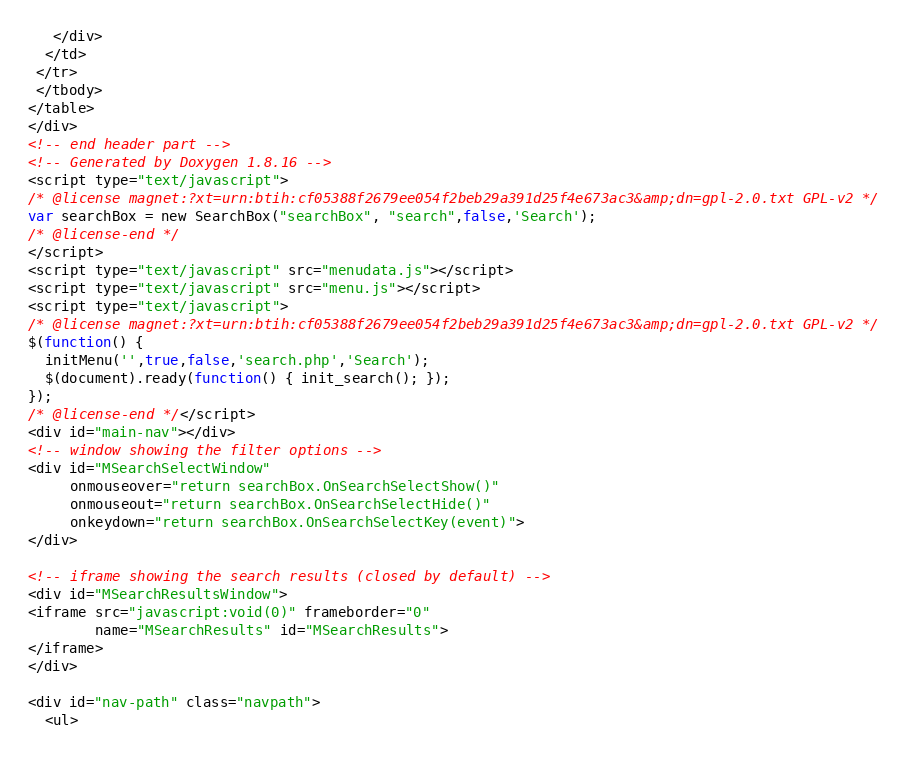Convert code to text. <code><loc_0><loc_0><loc_500><loc_500><_HTML_>   </div>
  </td>
 </tr>
 </tbody>
</table>
</div>
<!-- end header part -->
<!-- Generated by Doxygen 1.8.16 -->
<script type="text/javascript">
/* @license magnet:?xt=urn:btih:cf05388f2679ee054f2beb29a391d25f4e673ac3&amp;dn=gpl-2.0.txt GPL-v2 */
var searchBox = new SearchBox("searchBox", "search",false,'Search');
/* @license-end */
</script>
<script type="text/javascript" src="menudata.js"></script>
<script type="text/javascript" src="menu.js"></script>
<script type="text/javascript">
/* @license magnet:?xt=urn:btih:cf05388f2679ee054f2beb29a391d25f4e673ac3&amp;dn=gpl-2.0.txt GPL-v2 */
$(function() {
  initMenu('',true,false,'search.php','Search');
  $(document).ready(function() { init_search(); });
});
/* @license-end */</script>
<div id="main-nav"></div>
<!-- window showing the filter options -->
<div id="MSearchSelectWindow"
     onmouseover="return searchBox.OnSearchSelectShow()"
     onmouseout="return searchBox.OnSearchSelectHide()"
     onkeydown="return searchBox.OnSearchSelectKey(event)">
</div>

<!-- iframe showing the search results (closed by default) -->
<div id="MSearchResultsWindow">
<iframe src="javascript:void(0)" frameborder="0" 
        name="MSearchResults" id="MSearchResults">
</iframe>
</div>

<div id="nav-path" class="navpath">
  <ul></code> 